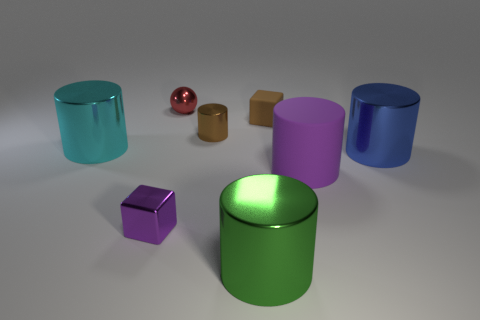Subtract all large purple matte cylinders. How many cylinders are left? 4 Add 2 gray metallic spheres. How many objects exist? 10 Subtract all brown cubes. How many cubes are left? 1 Subtract 2 cylinders. How many cylinders are left? 3 Subtract 0 purple spheres. How many objects are left? 8 Subtract all cylinders. How many objects are left? 3 Subtract all purple cylinders. Subtract all green spheres. How many cylinders are left? 4 Subtract all cyan cylinders. How many brown blocks are left? 1 Subtract all red cylinders. Subtract all matte cylinders. How many objects are left? 7 Add 4 small brown cubes. How many small brown cubes are left? 5 